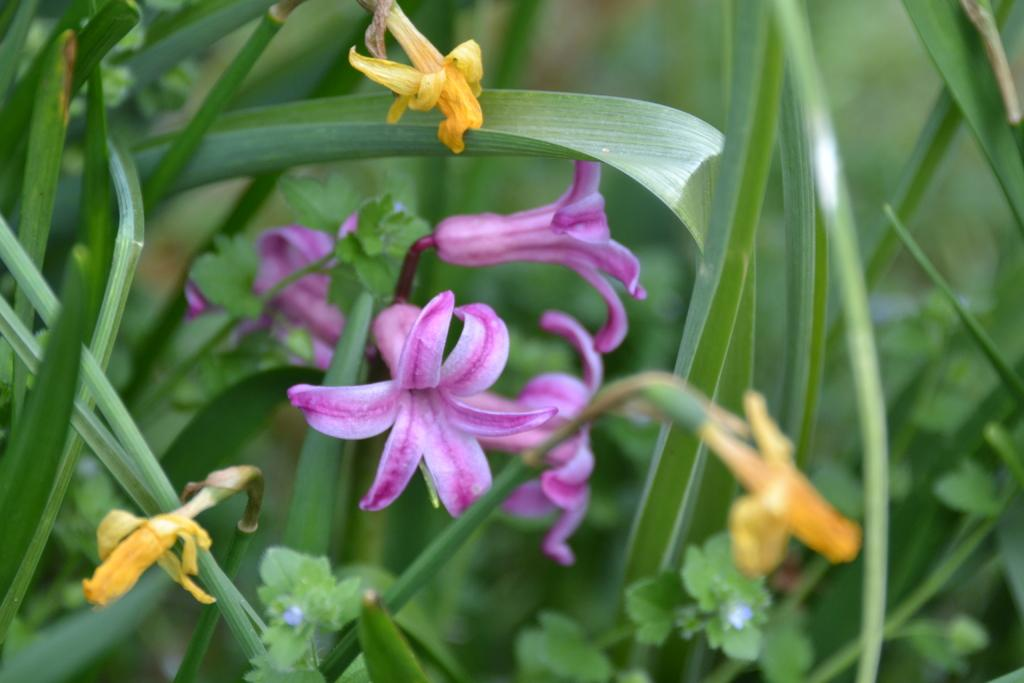What type of plant life is visible in the image? There are flowers, leaves of a plant, and grass in the image. Can you describe the different elements of plant life in the image? The image features flowers, leaves of a plant, and grass. What is the natural environment depicted in the image? The image shows a natural environment with flowers, leaves, and grass. What type of hearing aid is visible in the image? There is no hearing aid present in the image; it features flowers, leaves, and grass. 